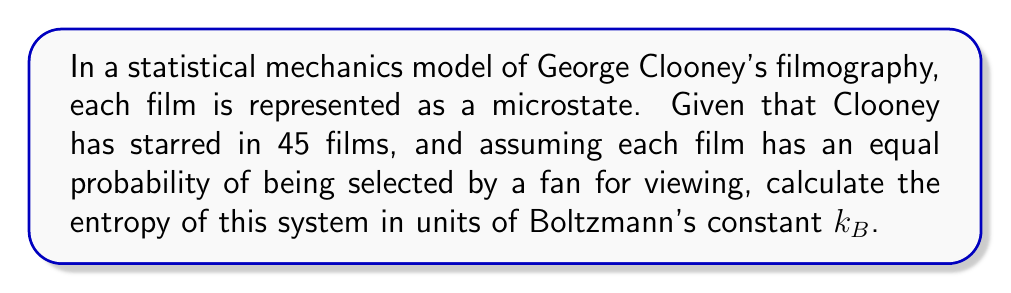What is the answer to this math problem? Let's approach this step-by-step:

1) In statistical mechanics, entropy $S$ is given by the Boltzmann formula:

   $$S = k_B \ln W$$

   where $k_B$ is Boltzmann's constant and $W$ is the number of microstates.

2) In this case, each film represents a microstate, and we have 45 films in total.

3) Given that each film has an equal probability of being selected, we can use the formula for the entropy of a system with equal probabilities:

   $$S = k_B \ln W = -k_B \sum_{i=1}^W p_i \ln p_i$$

   where $p_i$ is the probability of each microstate.

4) With 45 films, the probability of selecting any particular film is:

   $$p_i = \frac{1}{45}$$

5) Substituting this into our entropy formula:

   $$S = -k_B \sum_{i=1}^{45} \frac{1}{45} \ln \frac{1}{45}$$

6) This simplifies to:

   $$S = -k_B \cdot 45 \cdot \frac{1}{45} \ln \frac{1}{45} = -k_B \ln \frac{1}{45} = k_B \ln 45$$

7) Therefore, the entropy of the system is $k_B \ln 45$.
Answer: $k_B \ln 45$ 